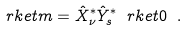<formula> <loc_0><loc_0><loc_500><loc_500>\ r k e t { m } = { \hat { X } } _ { \nu } ^ { * } { \hat { Y } } _ { s } ^ { * } \ r k e t { 0 } \ .</formula> 